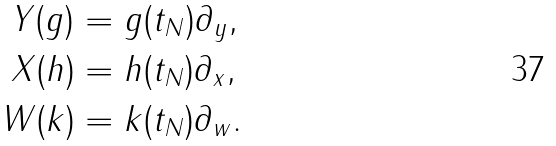Convert formula to latex. <formula><loc_0><loc_0><loc_500><loc_500>Y ( g ) & = g ( t _ { N } ) \partial _ { y } , \\ X ( h ) & = h ( t _ { N } ) \partial _ { x } , \\ W ( k ) & = k ( t _ { N } ) \partial _ { w } .</formula> 